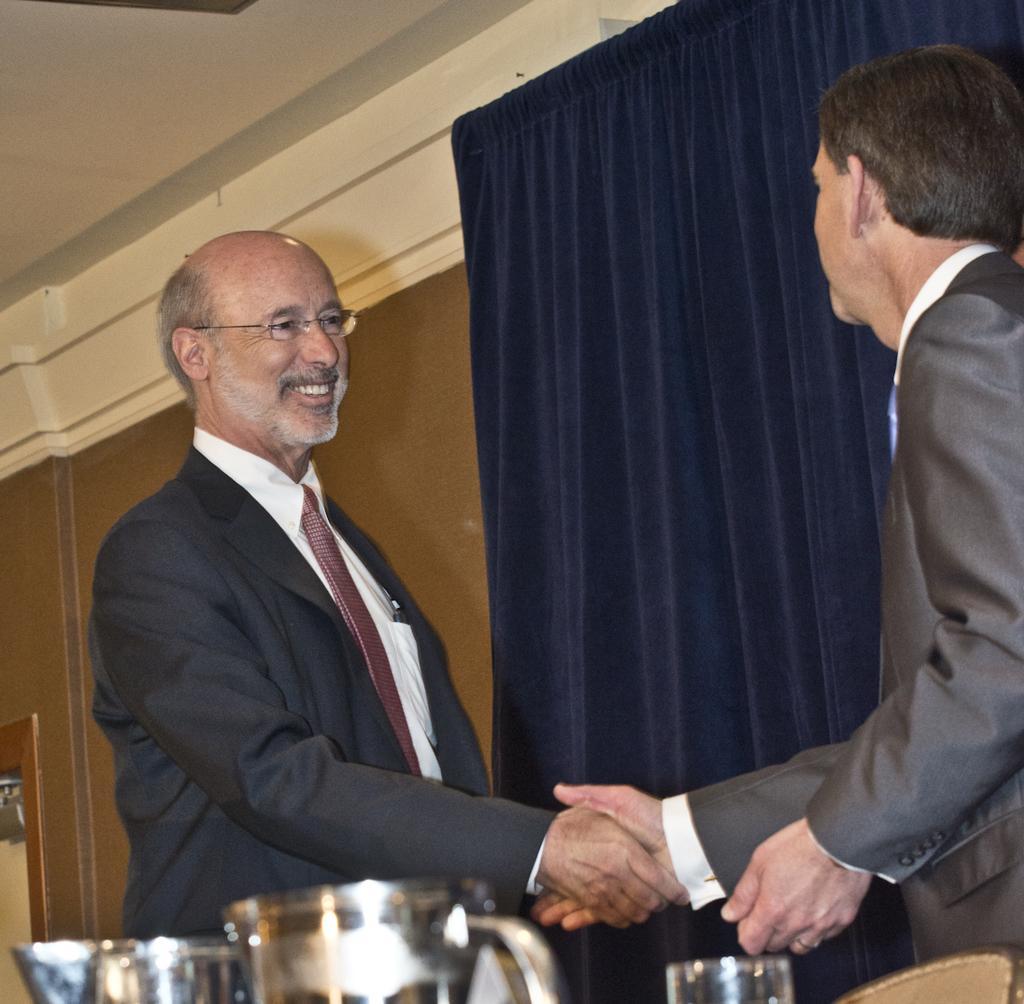Could you give a brief overview of what you see in this image? In this picture I can see two persons wearing coat and shaking hands. I can see the curtain. 